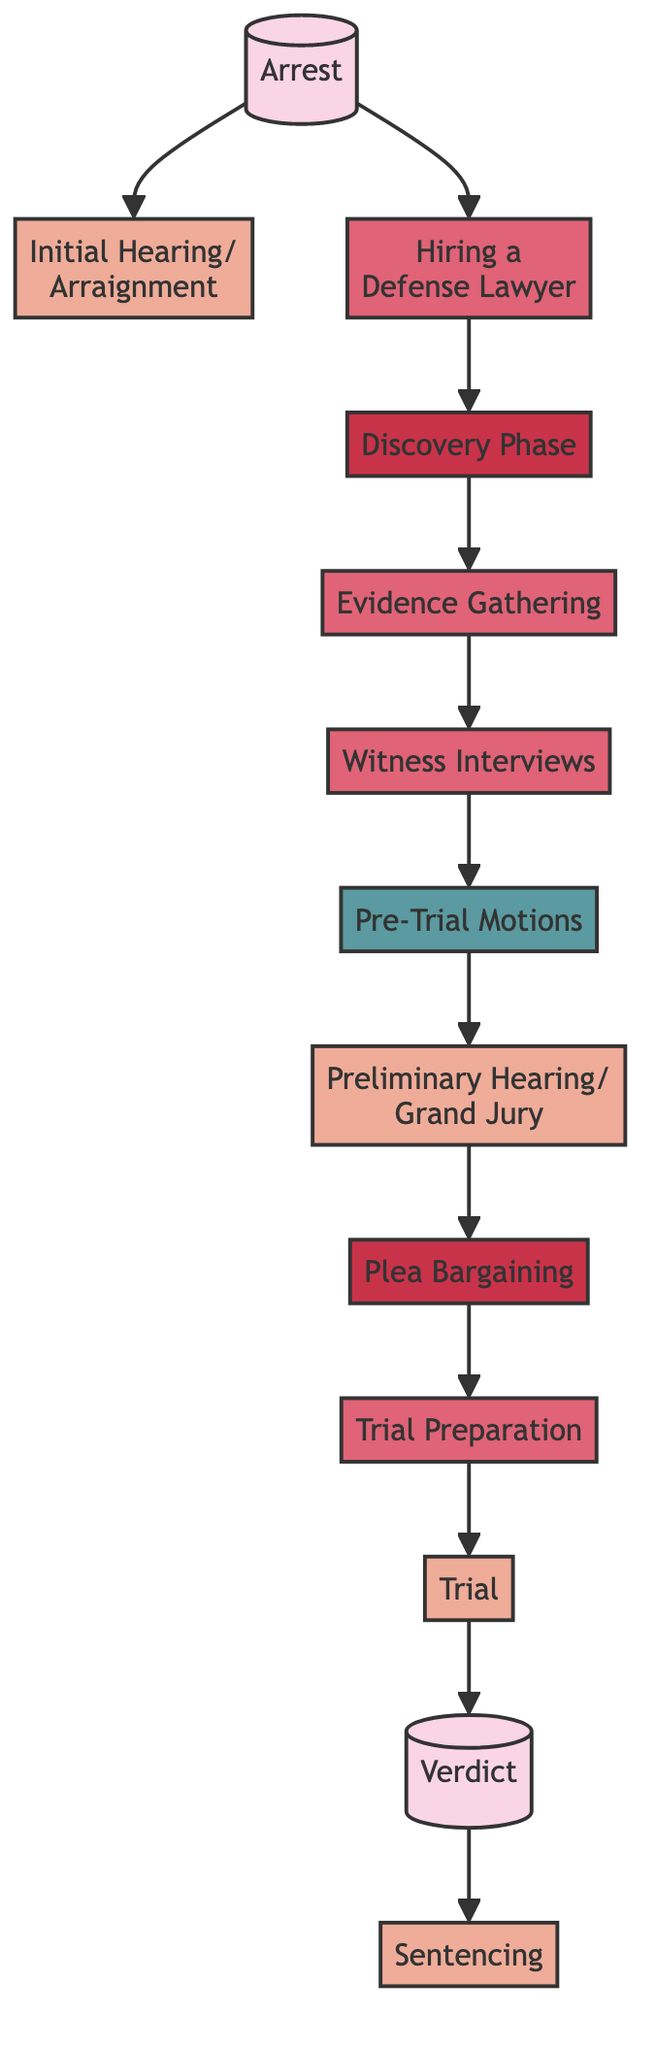What is the first event in the diagram? The first event is represented by the node labeled "Arrest", which has no dependencies and signifies the commencement of the process. It is the starting point for all subsequent nodes.
Answer: Arrest How many court dates are shown in the diagram? By examining the nodes of the diagram, there are a total of four court dates: "Initial Hearing/Arraignment", "Preliminary Hearing/Grand Jury", "Trial", and "Sentencing". Counting these nodes gives the total.
Answer: 4 What action follows the "Discovery Phase"? The action that follows "Discovery Phase" is "Evidence Gathering". This is determined by observing the directional arrow from "Discovery Phase" to "Evidence Gathering", indicating a direct dependency.
Answer: Evidence Gathering What is the last event that occurs in the process? The last event is "Sentencing", which only occurs after the "Verdict" has been delivered. This is shown in the diagram by the connection leading from "Verdict" to "Sentencing".
Answer: Sentencing What legal motion is filed after witness interviews? The legal motion filed after "Witness Interviews" is "Pre-Trial Motions". The flow of the diagram shows that "Witness Interviews" leads directly to "Pre-Trial Motions", indicating the order of actions.
Answer: Pre-Trial Motions What process immediately precedes "Trial Preparation"? The process that immediately precedes "Trial Preparation" is "Plea Bargaining". The connection from "Plea Bargaining" to "Trial Preparation" confirms this as the direct predecessor event.
Answer: Plea Bargaining How many actions are listed in the diagram? There are five actions depicted in the diagram: "Hiring a Defense Lawyer", "Evidence Gathering", "Witness Interviews", "Trial Preparation", and "Trial". Counting these nodes gives the final result.
Answer: 5 What is the relationship between "Arrest" and "Initial Hearing/Arraignment"? The relationship is that "Initial Hearing/Arraignment" is dependent on "Arrest"; this can be seen from the directional arrow leading from "Arrest" to "Initial Hearing/Arraignment", indicating that the arrest must occur first.
Answer: Dependent What is the connection between "Verdict" and "Sentencing"? The connection is that "Sentencing" occurs after a "Verdict" is reached; in the flowchart, there is a direct arrow that indicates that "Sentencing" must follow "Verdict".
Answer: Occurs after 